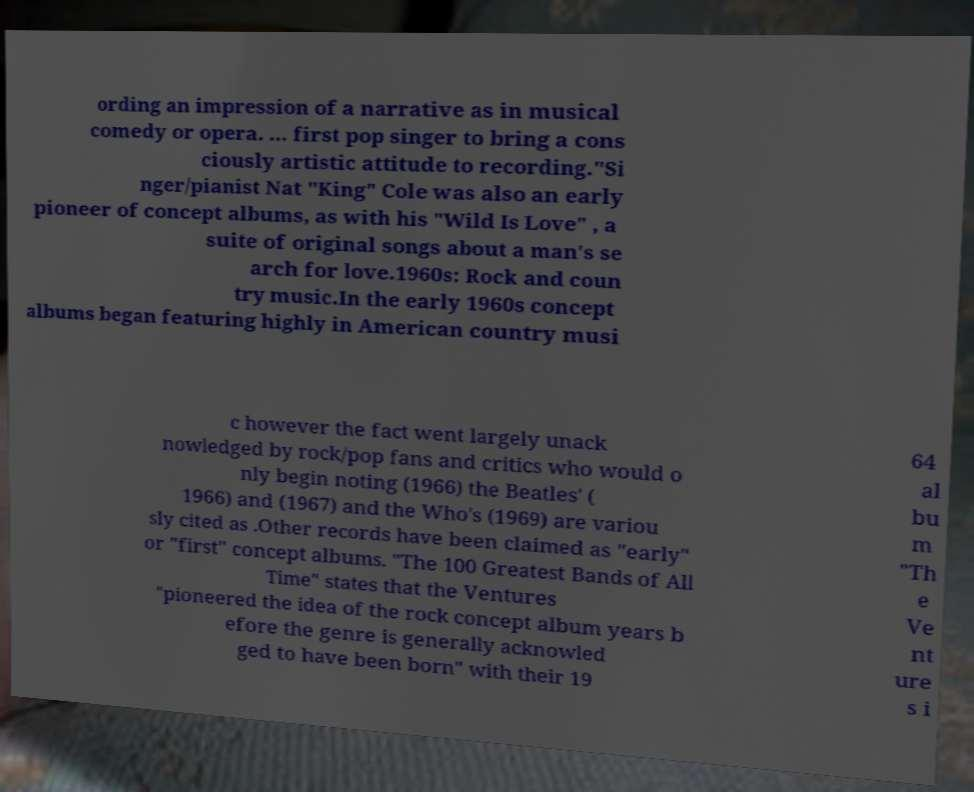Can you read and provide the text displayed in the image?This photo seems to have some interesting text. Can you extract and type it out for me? ording an impression of a narrative as in musical comedy or opera. ... first pop singer to bring a cons ciously artistic attitude to recording."Si nger/pianist Nat "King" Cole was also an early pioneer of concept albums, as with his "Wild Is Love" , a suite of original songs about a man's se arch for love.1960s: Rock and coun try music.In the early 1960s concept albums began featuring highly in American country musi c however the fact went largely unack nowledged by rock/pop fans and critics who would o nly begin noting (1966) the Beatles' ( 1966) and (1967) and the Who's (1969) are variou sly cited as .Other records have been claimed as "early" or "first" concept albums. "The 100 Greatest Bands of All Time" states that the Ventures "pioneered the idea of the rock concept album years b efore the genre is generally acknowled ged to have been born" with their 19 64 al bu m "Th e Ve nt ure s i 